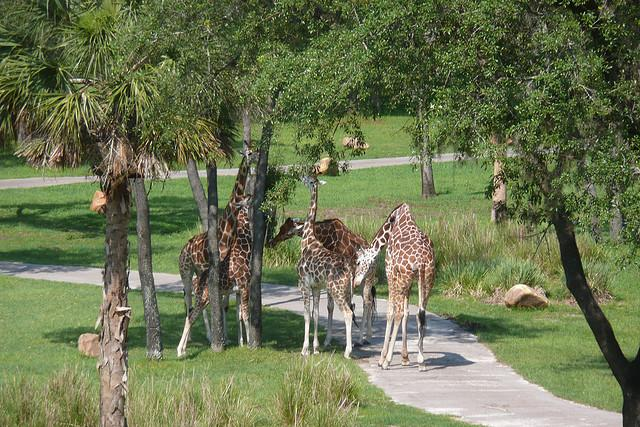What are the giraffes playing around? trees 